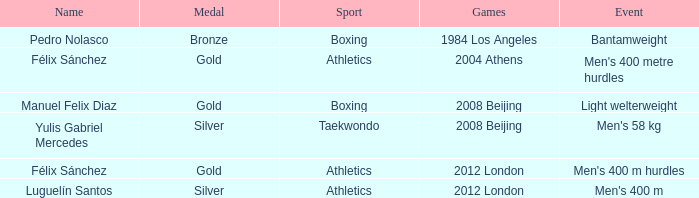Which Medal had a Name of félix sánchez, and a Games of 2012 london? Gold. 